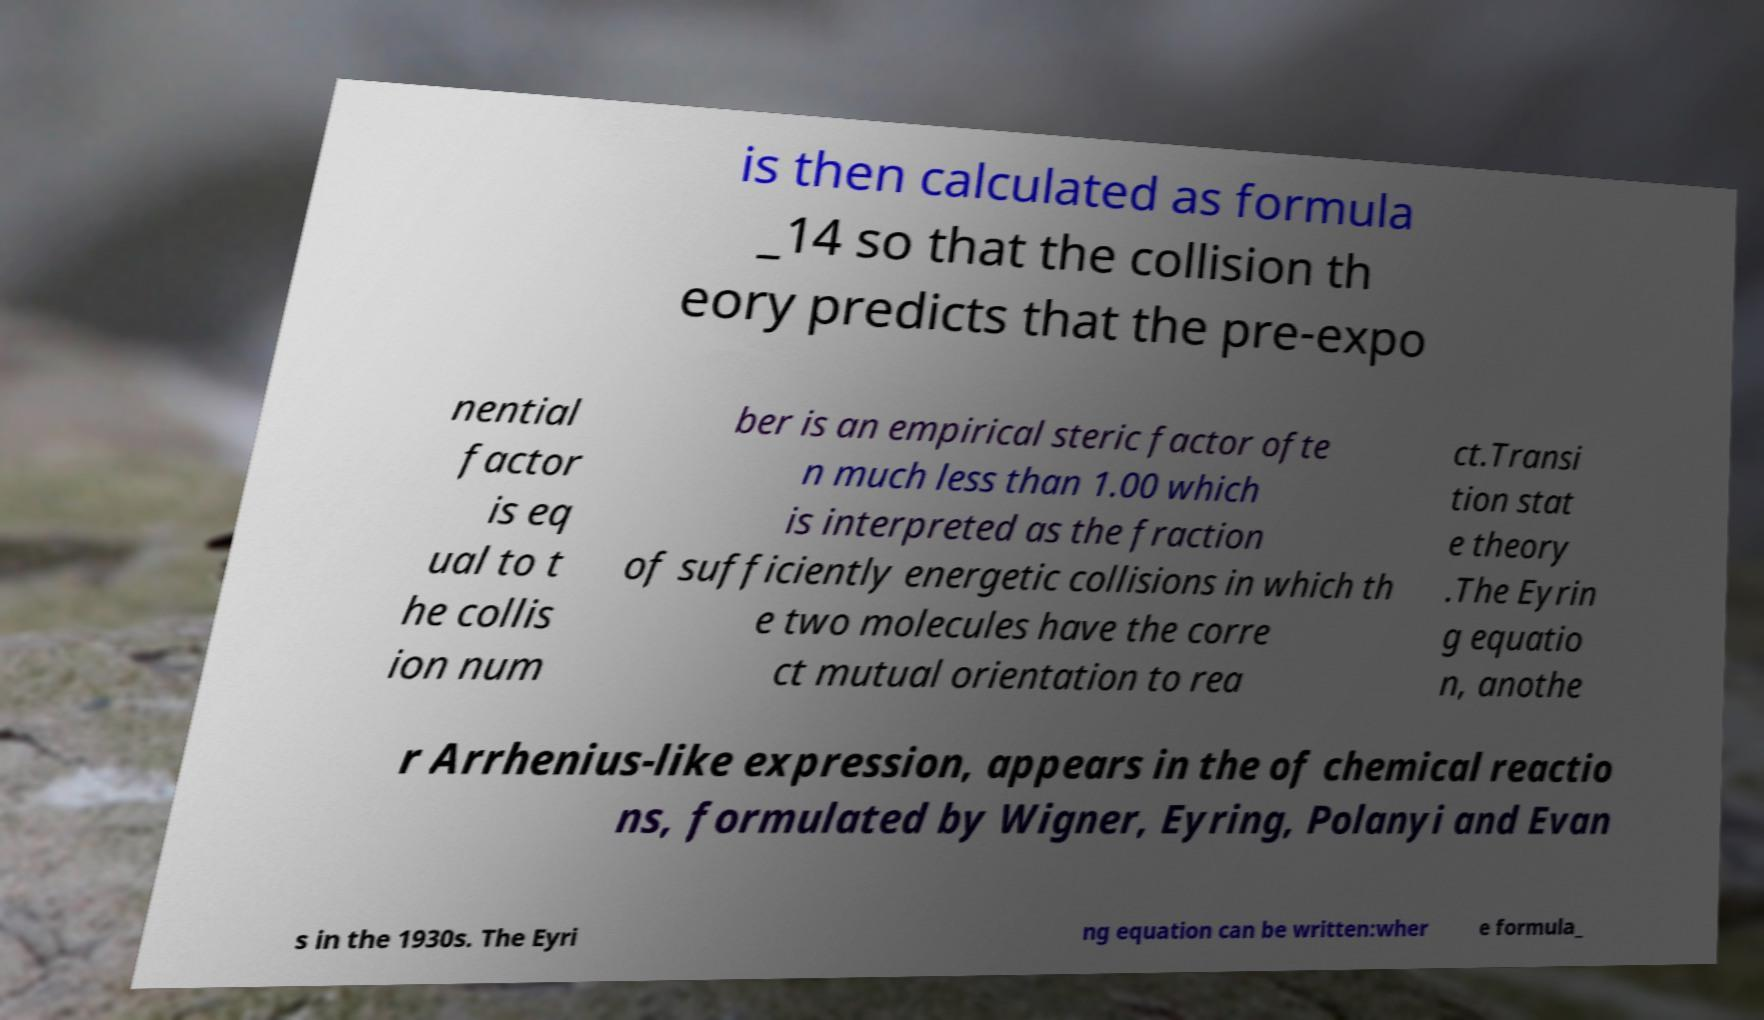Please read and relay the text visible in this image. What does it say? is then calculated as formula _14 so that the collision th eory predicts that the pre-expo nential factor is eq ual to t he collis ion num ber is an empirical steric factor ofte n much less than 1.00 which is interpreted as the fraction of sufficiently energetic collisions in which th e two molecules have the corre ct mutual orientation to rea ct.Transi tion stat e theory .The Eyrin g equatio n, anothe r Arrhenius-like expression, appears in the of chemical reactio ns, formulated by Wigner, Eyring, Polanyi and Evan s in the 1930s. The Eyri ng equation can be written:wher e formula_ 